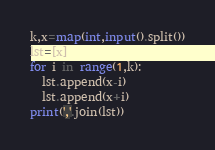<code> <loc_0><loc_0><loc_500><loc_500><_Python_>k,x=map(int,input().split())
lst=[x]
for i in range(1,k):
  lst.append(x-i)
  lst.append(x+i)
print(','.join(lst))
</code> 